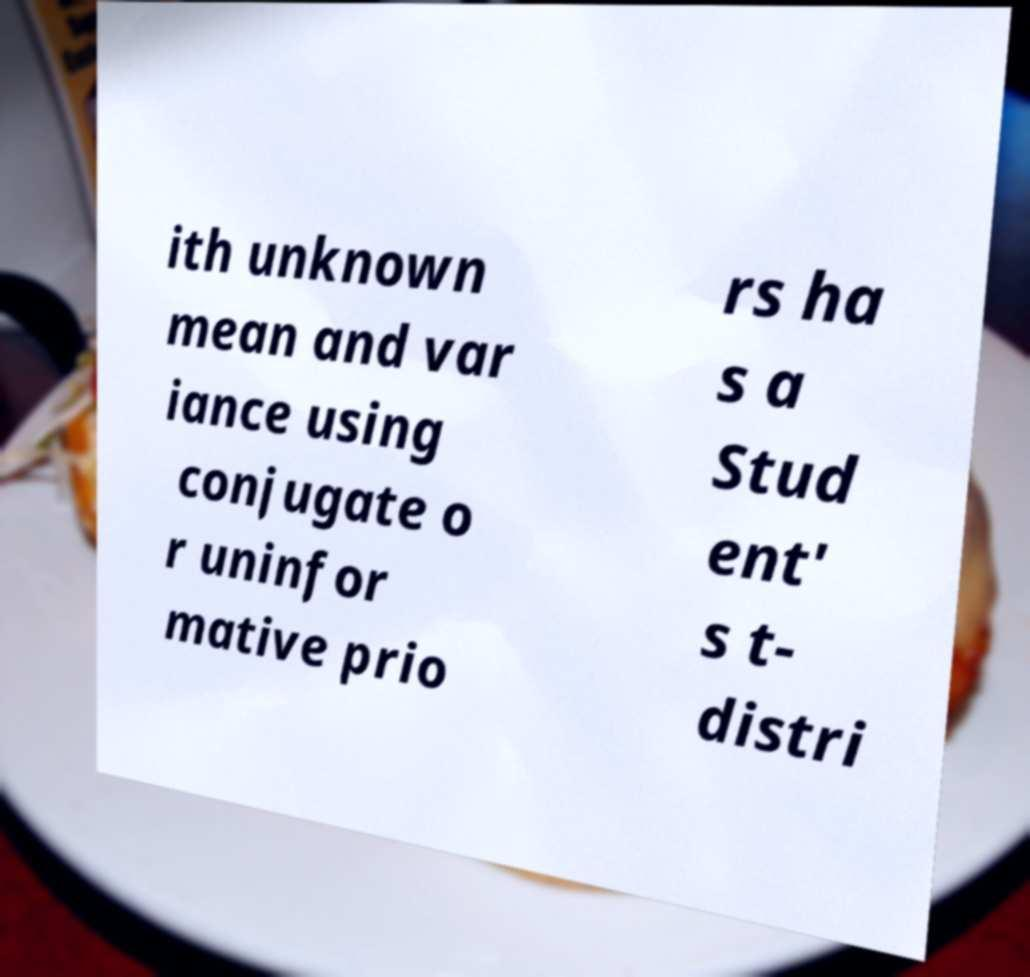I need the written content from this picture converted into text. Can you do that? ith unknown mean and var iance using conjugate o r uninfor mative prio rs ha s a Stud ent' s t- distri 